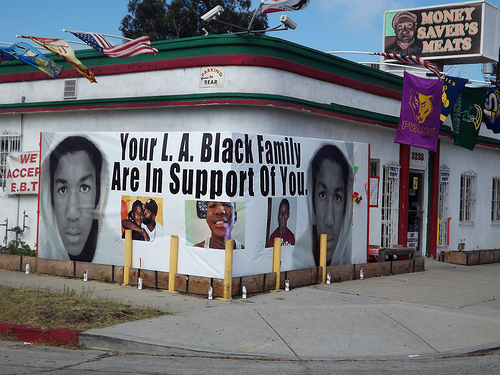<image>
Is there a building next to the board? Yes. The building is positioned adjacent to the board, located nearby in the same general area. Where is the building in relation to the road? Is it above the road? No. The building is not positioned above the road. The vertical arrangement shows a different relationship. 